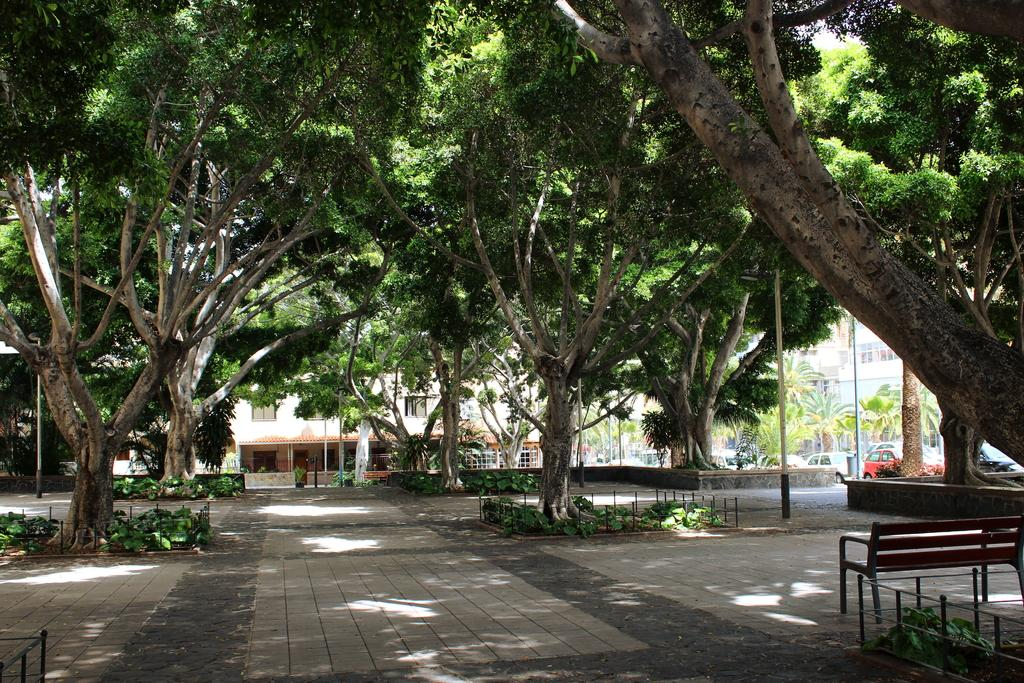What type of structures can be seen in the image? There are buildings in the image. What else is present in the image besides buildings? There are vehicles, trees, a fence, and plants in the image. What type of creature is performing on the stage in the image? There is no stage present in the image, so it is not possible to answer that question. 